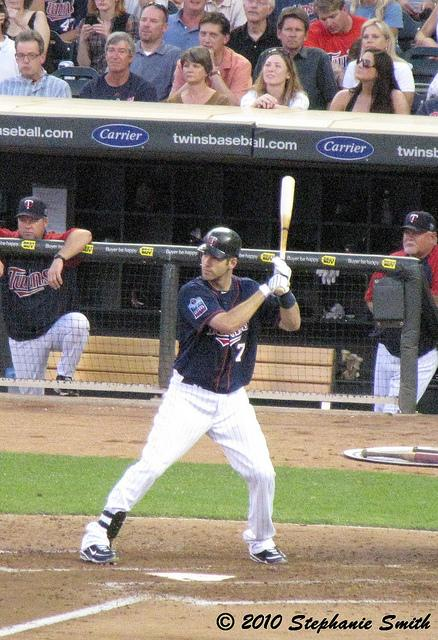What is the name of the batter? joe mauer 